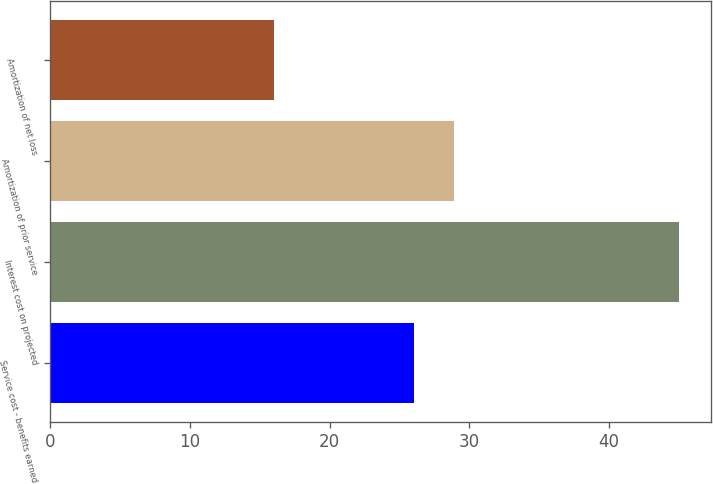<chart> <loc_0><loc_0><loc_500><loc_500><bar_chart><fcel>Service cost - benefits earned<fcel>Interest cost on projected<fcel>Amortization of prior service<fcel>Amortization of net loss<nl><fcel>26<fcel>45<fcel>28.9<fcel>16<nl></chart> 